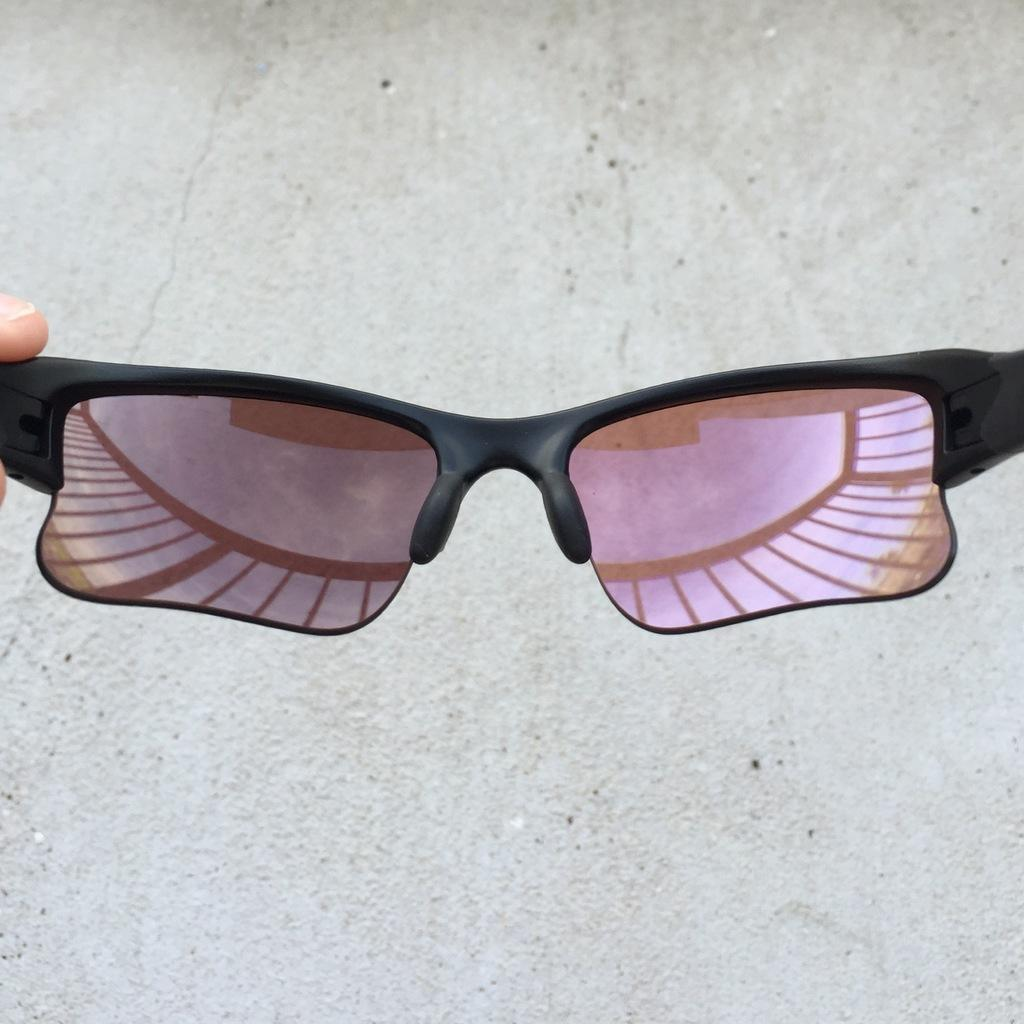What is the person holding in the image? The person is holding sunglasses in the image. Can you describe the person's finger in the image? The person's finger is visible in the image. What can be seen in the reflection of the sunglasses? The reflection shows the sky and clouds. What is visible in the background of the image? The floor is visible in the background of the image. What type of committee can be seen in the image? There is no committee present in the image; it features a person holding sunglasses. Can you describe the nest in the image? There is no nest present in the image. 